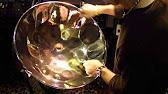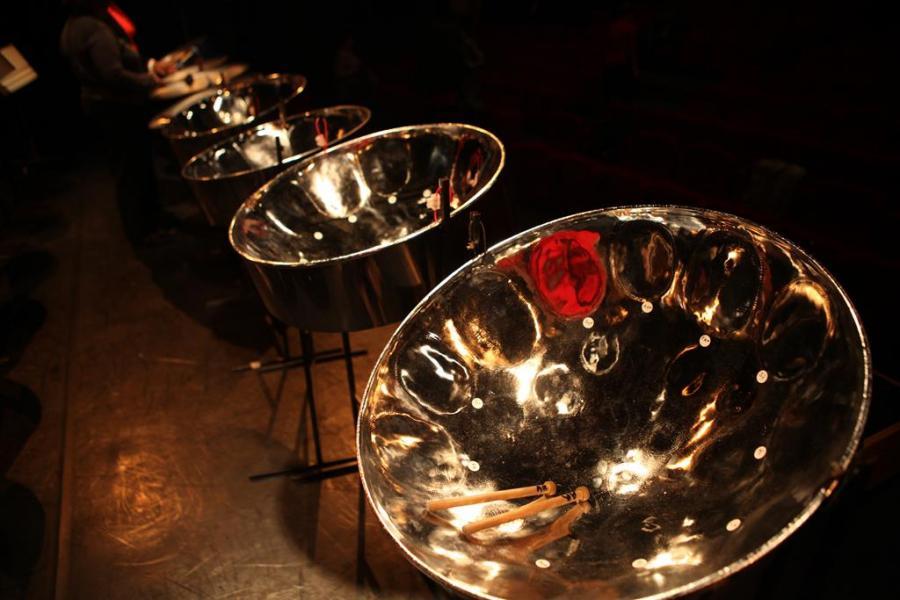The first image is the image on the left, the second image is the image on the right. Considering the images on both sides, is "The left image contains a row of three musicians in matching shirts, and at least one of them holds drumsticks and has a steel drum at his front." valid? Answer yes or no. No. 